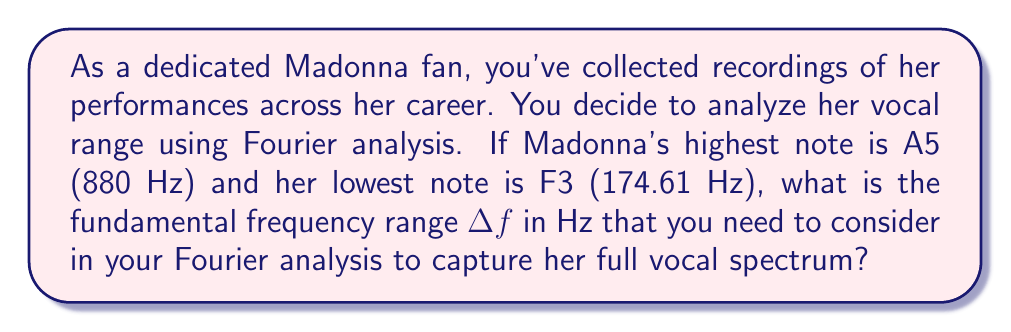Can you solve this math problem? To determine the frequency spectrum using Fourier analysis, we need to consider the range of frequencies in Madonna's vocal performance. Let's approach this step-by-step:

1) Identify the highest and lowest frequencies:
   - Highest note (A5): $f_h = 880$ Hz
   - Lowest note (F3): $f_l = 174.61$ Hz

2) The fundamental frequency range $\Delta f$ is the difference between the highest and lowest frequencies:

   $$\Delta f = f_h - f_l$$

3) Substitute the values:

   $$\Delta f = 880 \text{ Hz} - 174.61 \text{ Hz}$$

4) Calculate the difference:

   $$\Delta f = 705.39 \text{ Hz}$$

This range represents the minimum frequency span that needs to be analyzed to capture Madonna's full vocal spectrum. In practice, you might want to extend this range slightly to account for harmonics and overtones, but this calculation gives you the core range for her vocals.
Answer: $705.39 \text{ Hz}$ 